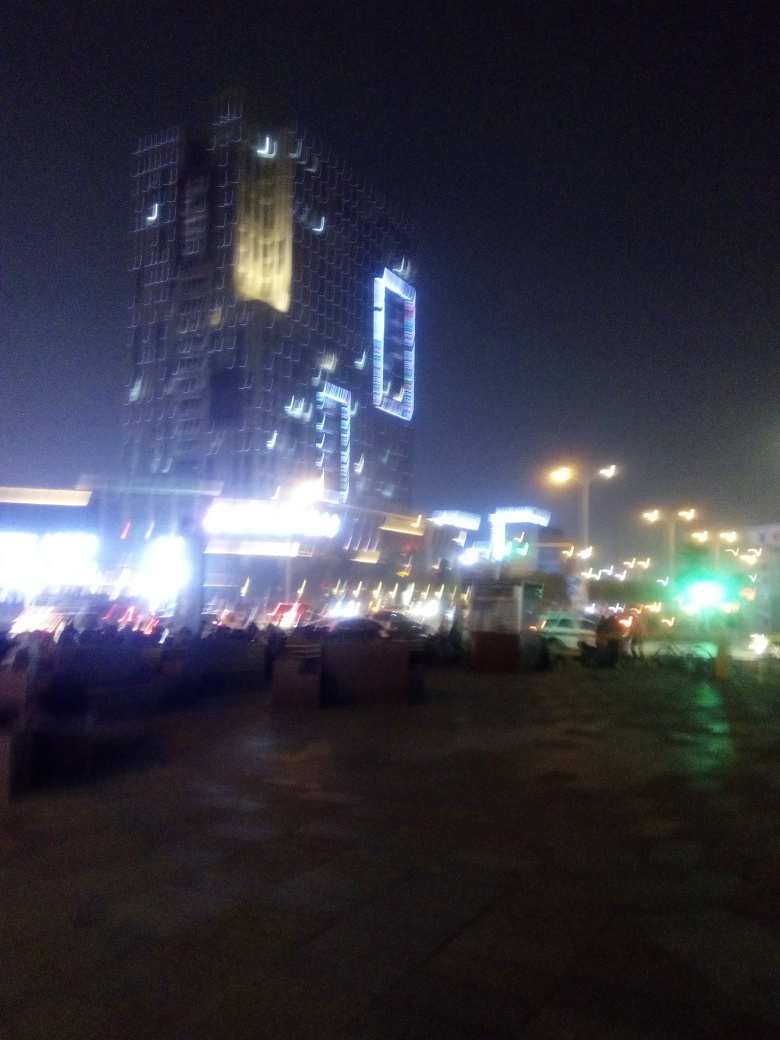What time of day does this image depict? The image appears to capture a scene during the evening or nighttime, as indicated by the artificial lighting on the buildings and streets, and the darkness of the sky. 